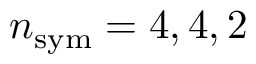<formula> <loc_0><loc_0><loc_500><loc_500>n _ { s y m } = 4 , 4 , 2</formula> 